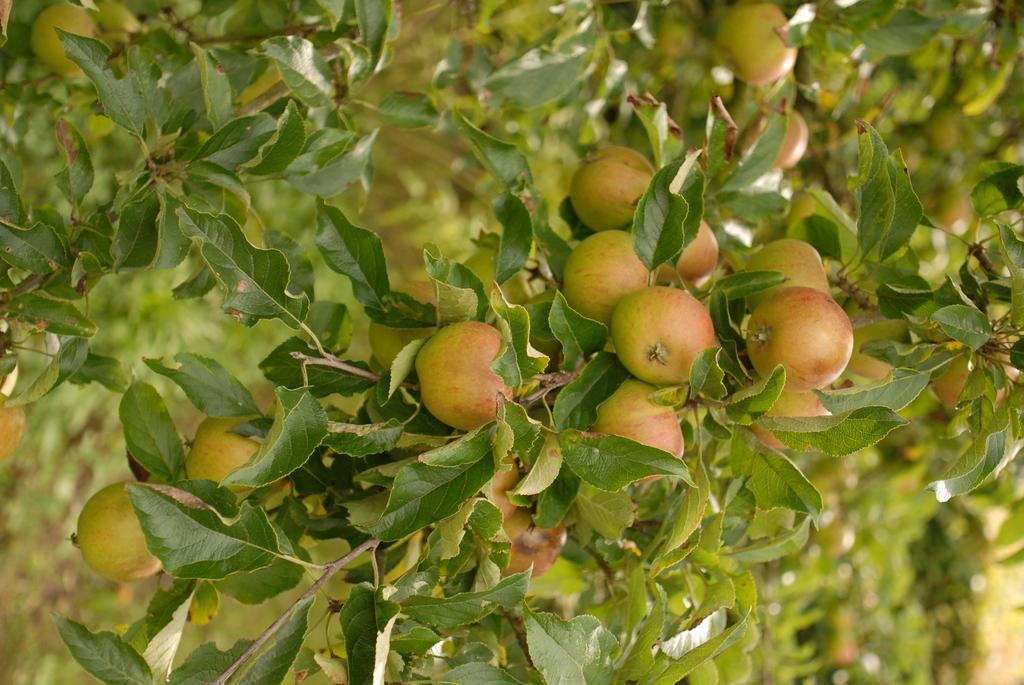What is the main subject of the image? The main subject of the image is a branch of a tree. What can be seen on the branch? The branch has fruits and green leaves. What can be observed in the background of the image? There are other trees with fruits and leaves in the background of the image. How many hens are sitting on the branch in the image? There are no hens present in the image; the branch has fruits and green leaves. What is the fifth fruit on the branch? The provided facts do not specify the number of fruits on the branch, so it is impossible to determine the fifth fruit. 